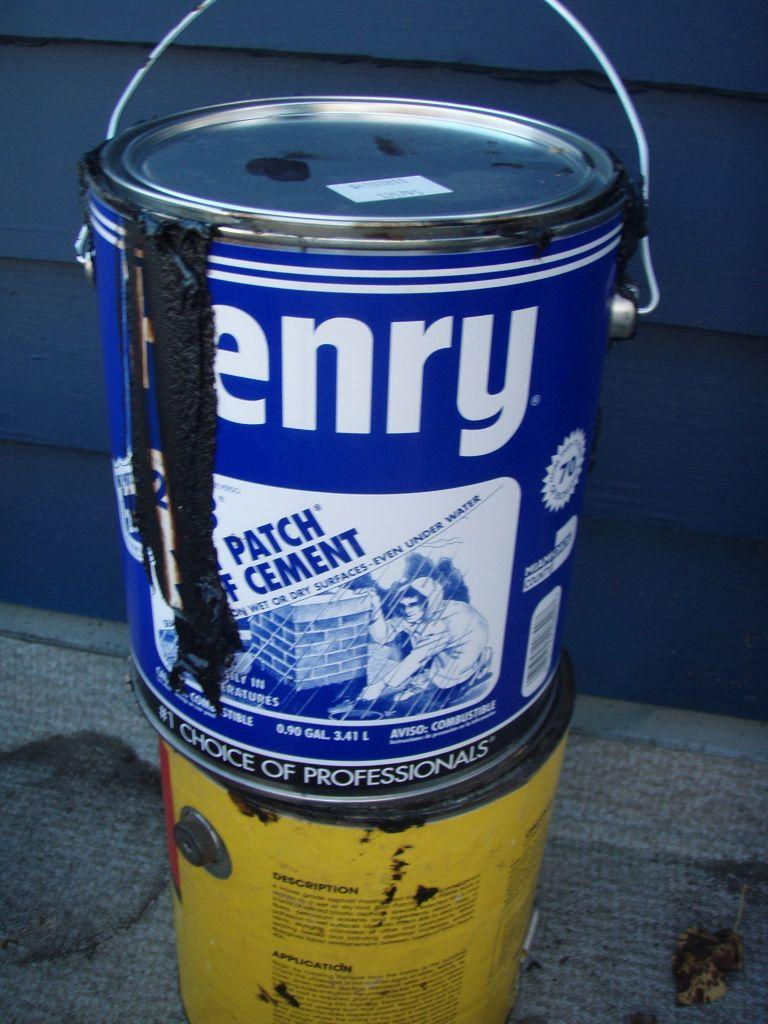Provide a one-sentence caption for the provided image. A tin of Henry cement that still has its contents dribbling down its side rests on another tin. 